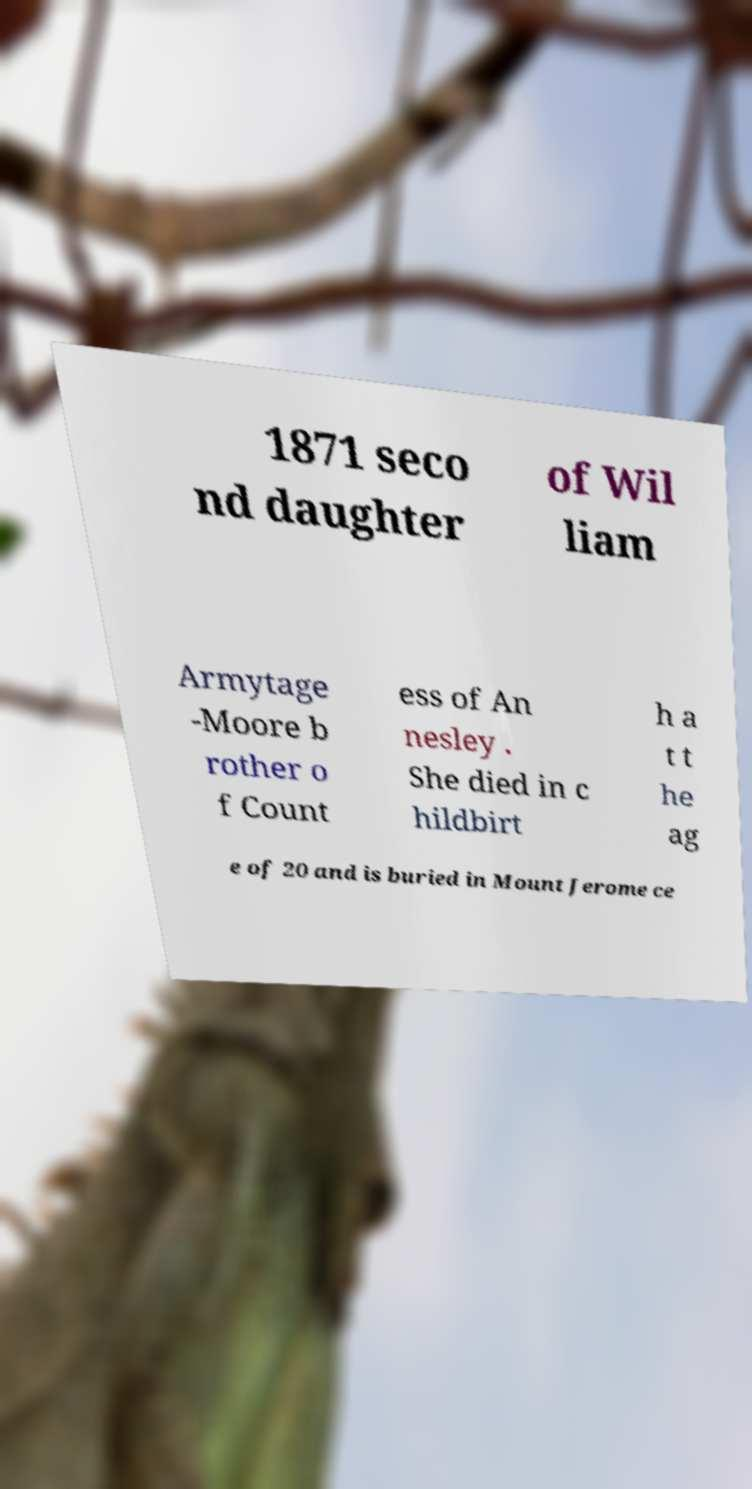Can you read and provide the text displayed in the image?This photo seems to have some interesting text. Can you extract and type it out for me? 1871 seco nd daughter of Wil liam Armytage -Moore b rother o f Count ess of An nesley . She died in c hildbirt h a t t he ag e of 20 and is buried in Mount Jerome ce 